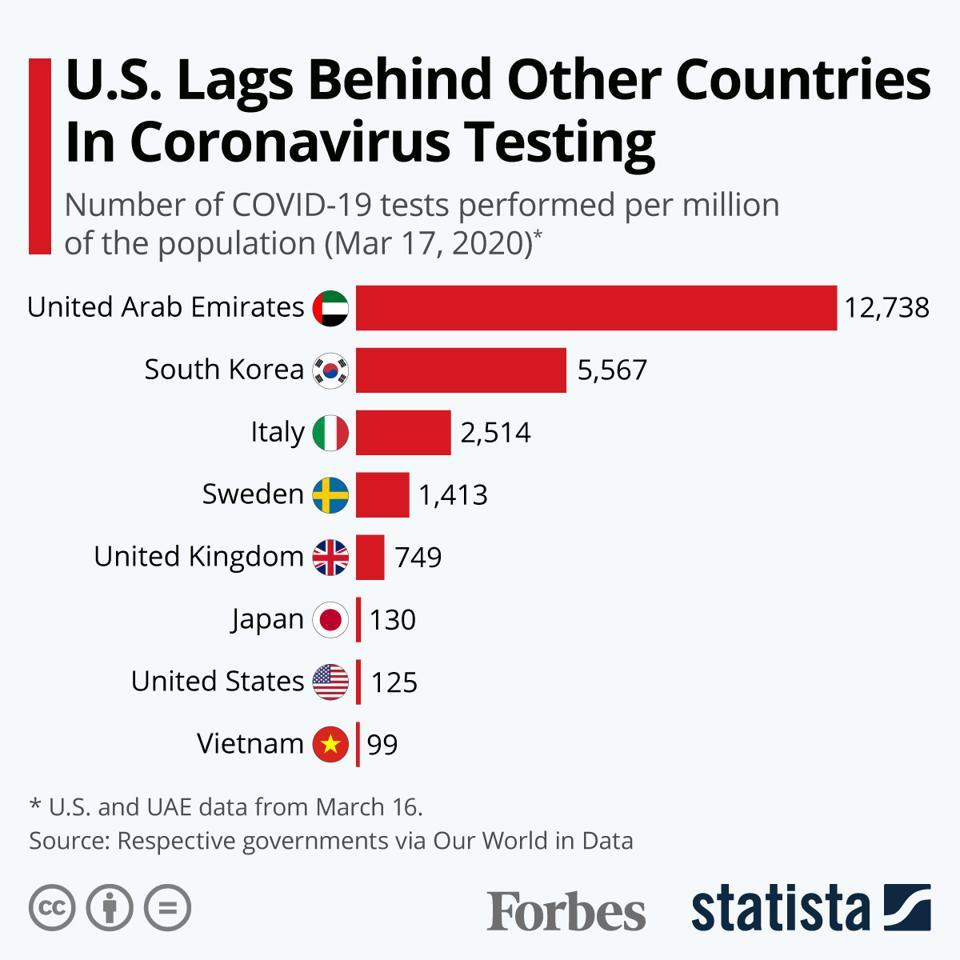Give some essential details in this illustration. As of March 17, 2020, there have been approximately 130 COVID-19 tests performed per million of the population in Japan. As of March 17, 2020, the number of COVID-19 tests performed per million of the population in Italy was 2,514. The United Arab Emirates (UAE) has conducted the highest number of COVID-19 tests per million population among the given countries as of March 17, 2020. Among the given countries, Vietnam has performed the lowest number of COVID-19 tests per million population as of March 17, 2020. As of March 17, 2020, the number of COVID-19 tests performed per million of the population in the UK was 749. This indicates a high level of testing activity in the country, reflecting the ongoing efforts to monitor and control the spread of the virus. 